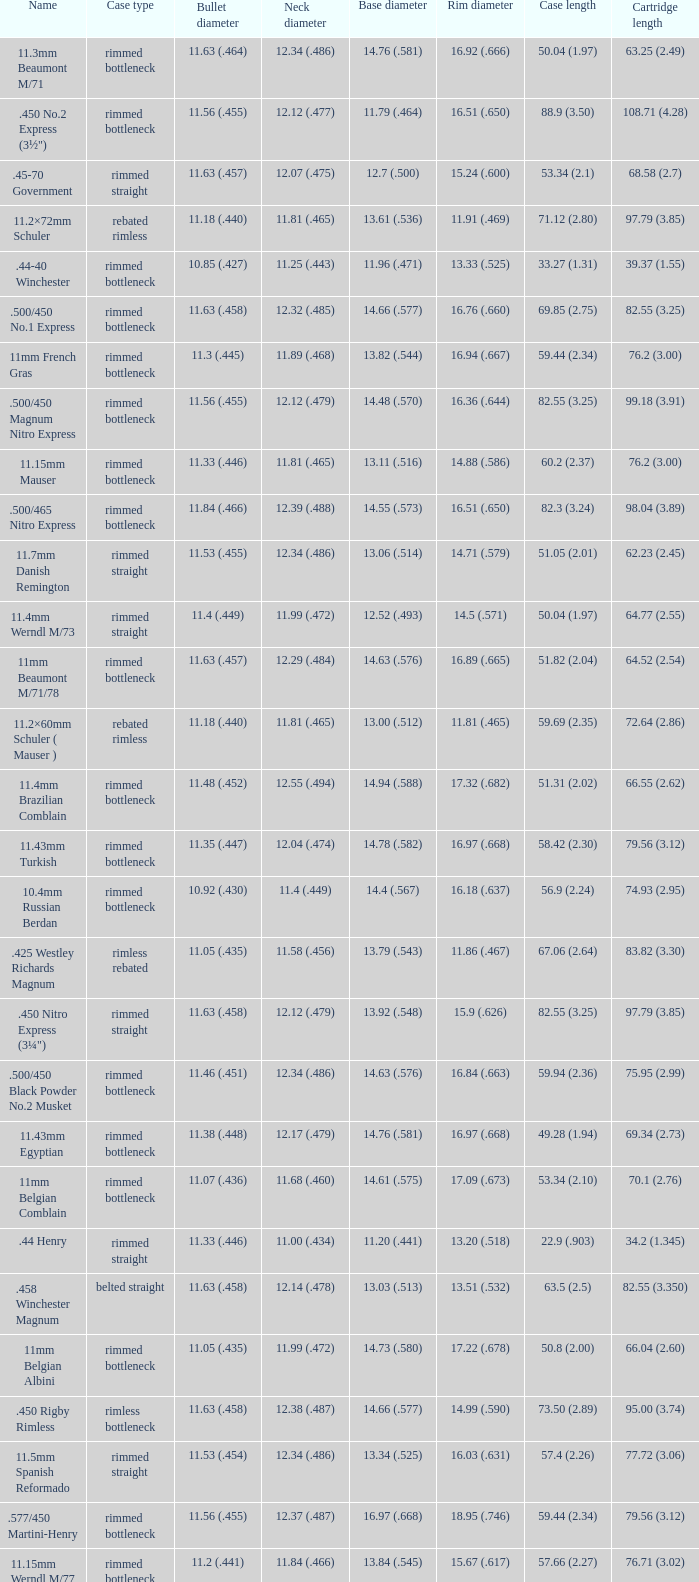Which Rim diameter has a Neck diameter of 11.84 (.466)? 15.67 (.617). 